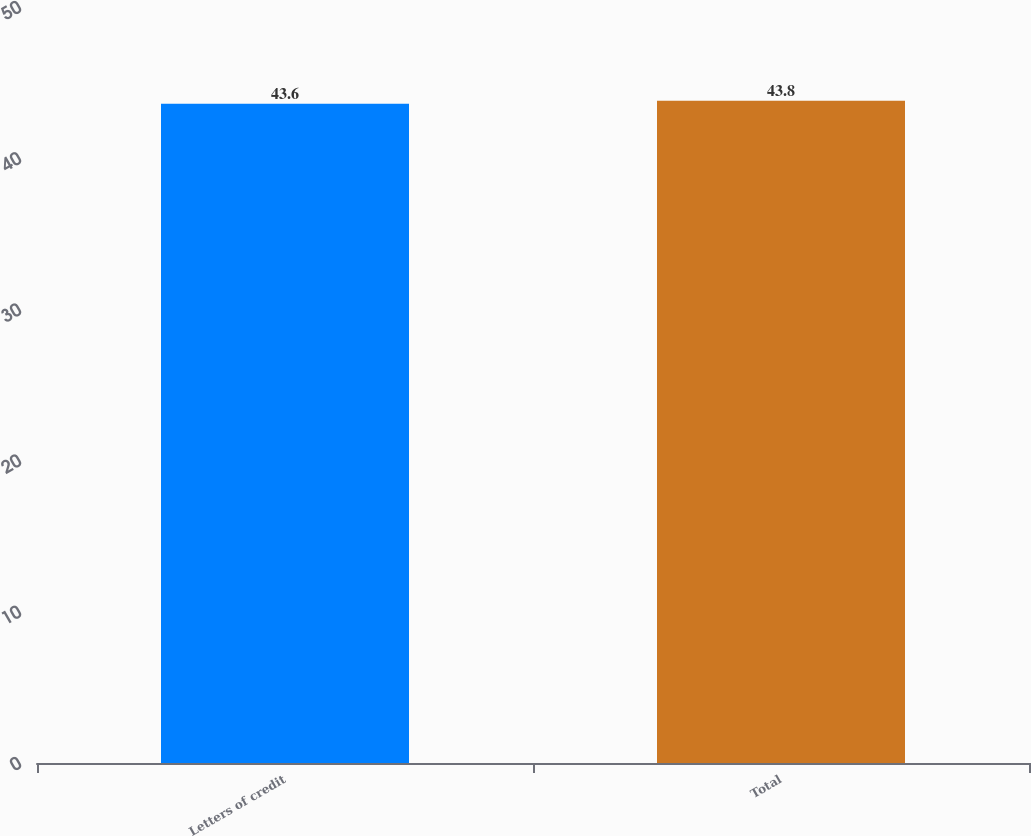Convert chart. <chart><loc_0><loc_0><loc_500><loc_500><bar_chart><fcel>Letters of credit<fcel>Total<nl><fcel>43.6<fcel>43.8<nl></chart> 